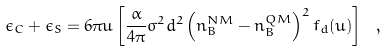Convert formula to latex. <formula><loc_0><loc_0><loc_500><loc_500>\epsilon _ { C } + \epsilon _ { S } = 6 \pi u \left [ \frac { \alpha } { 4 \pi } \sigma ^ { 2 } d ^ { 2 } \left ( n _ { B } ^ { N M } - n _ { B } ^ { Q M } \right ) ^ { 2 } f _ { d } ( u ) \right ] \ ,</formula> 